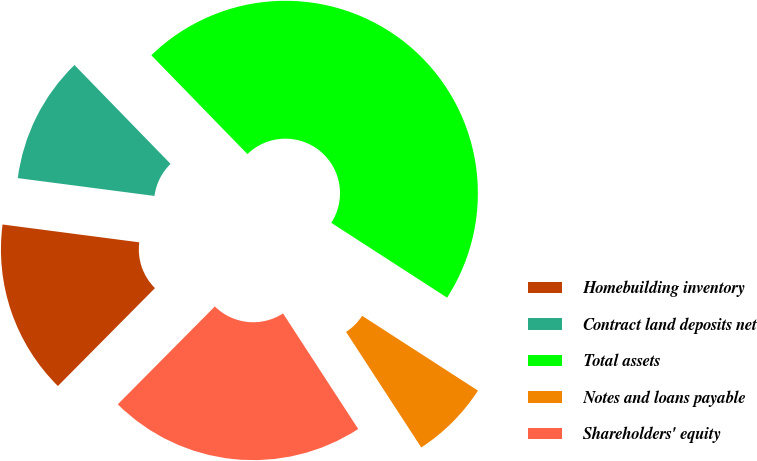<chart> <loc_0><loc_0><loc_500><loc_500><pie_chart><fcel>Homebuilding inventory<fcel>Contract land deposits net<fcel>Total assets<fcel>Notes and loans payable<fcel>Shareholders' equity<nl><fcel>14.63%<fcel>10.66%<fcel>46.4%<fcel>6.69%<fcel>21.61%<nl></chart> 